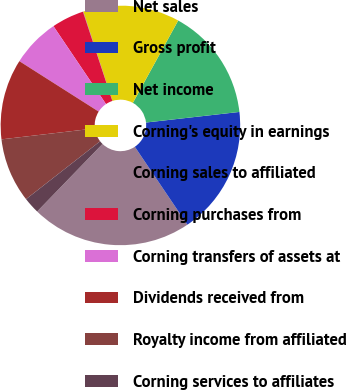<chart> <loc_0><loc_0><loc_500><loc_500><pie_chart><fcel>Net sales<fcel>Gross profit<fcel>Net income<fcel>Corning's equity in earnings<fcel>Corning sales to affiliated<fcel>Corning purchases from<fcel>Corning transfers of assets at<fcel>Dividends received from<fcel>Royalty income from affiliated<fcel>Corning services to affiliates<nl><fcel>21.68%<fcel>17.35%<fcel>15.19%<fcel>13.03%<fcel>0.05%<fcel>4.38%<fcel>6.54%<fcel>10.87%<fcel>8.7%<fcel>2.21%<nl></chart> 